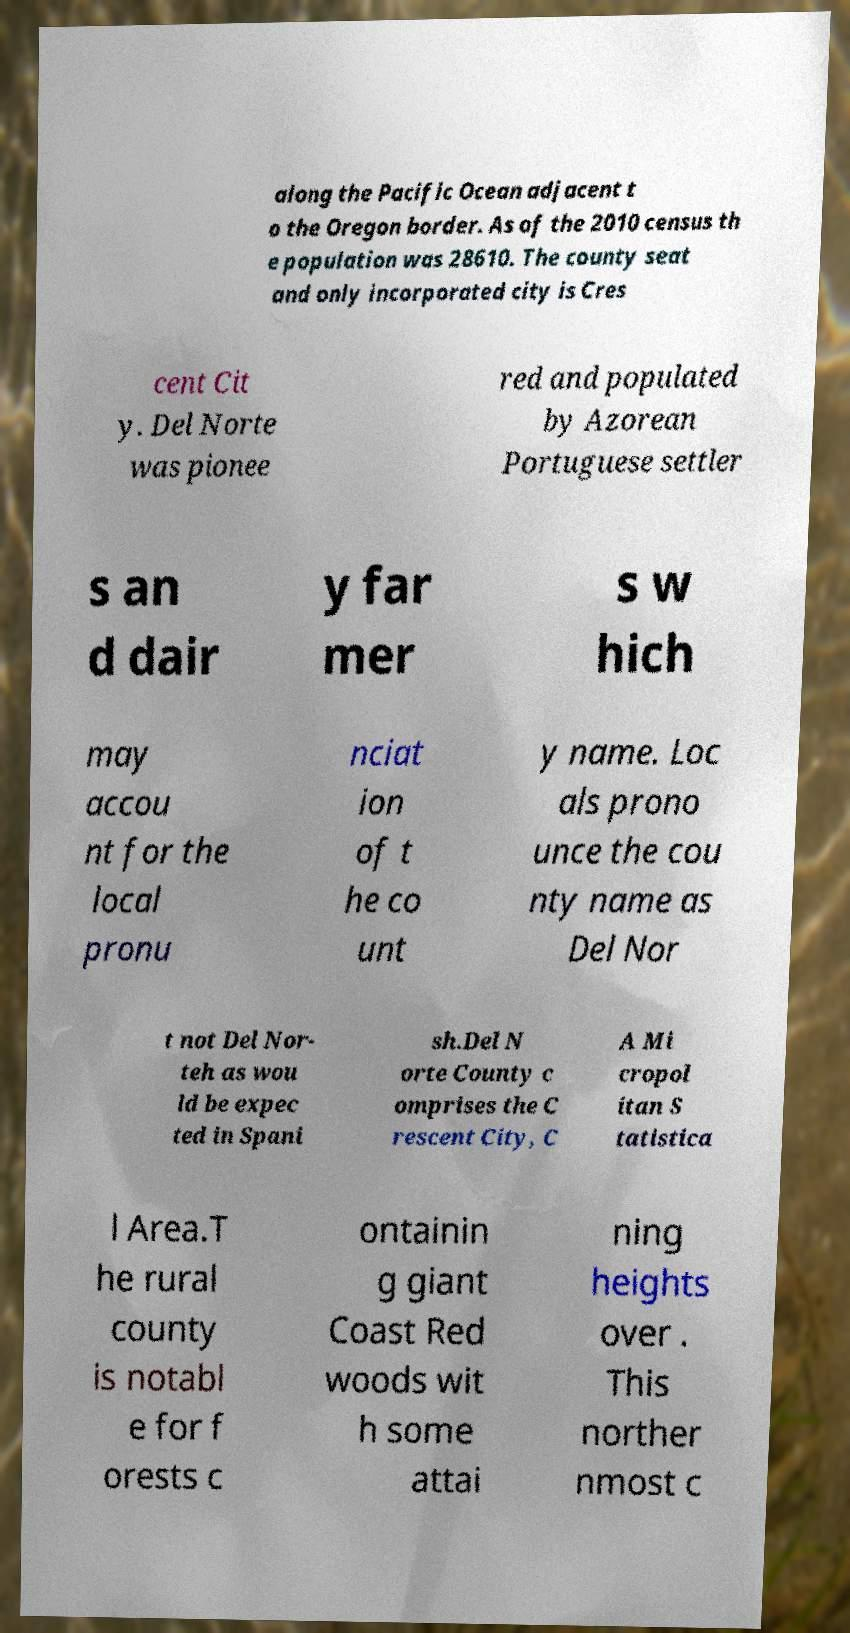Could you assist in decoding the text presented in this image and type it out clearly? along the Pacific Ocean adjacent t o the Oregon border. As of the 2010 census th e population was 28610. The county seat and only incorporated city is Cres cent Cit y. Del Norte was pionee red and populated by Azorean Portuguese settler s an d dair y far mer s w hich may accou nt for the local pronu nciat ion of t he co unt y name. Loc als prono unce the cou nty name as Del Nor t not Del Nor- teh as wou ld be expec ted in Spani sh.Del N orte County c omprises the C rescent City, C A Mi cropol itan S tatistica l Area.T he rural county is notabl e for f orests c ontainin g giant Coast Red woods wit h some attai ning heights over . This norther nmost c 